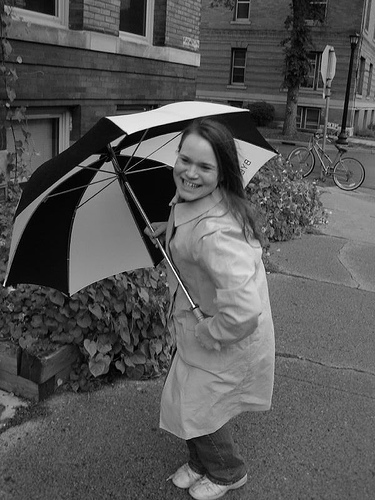<image>Was it taken in Summer? No, the image was not taken in Summer. Was it taken in Summer? I don't know if it was taken in Summer. It is most likely not taken in Summer. 